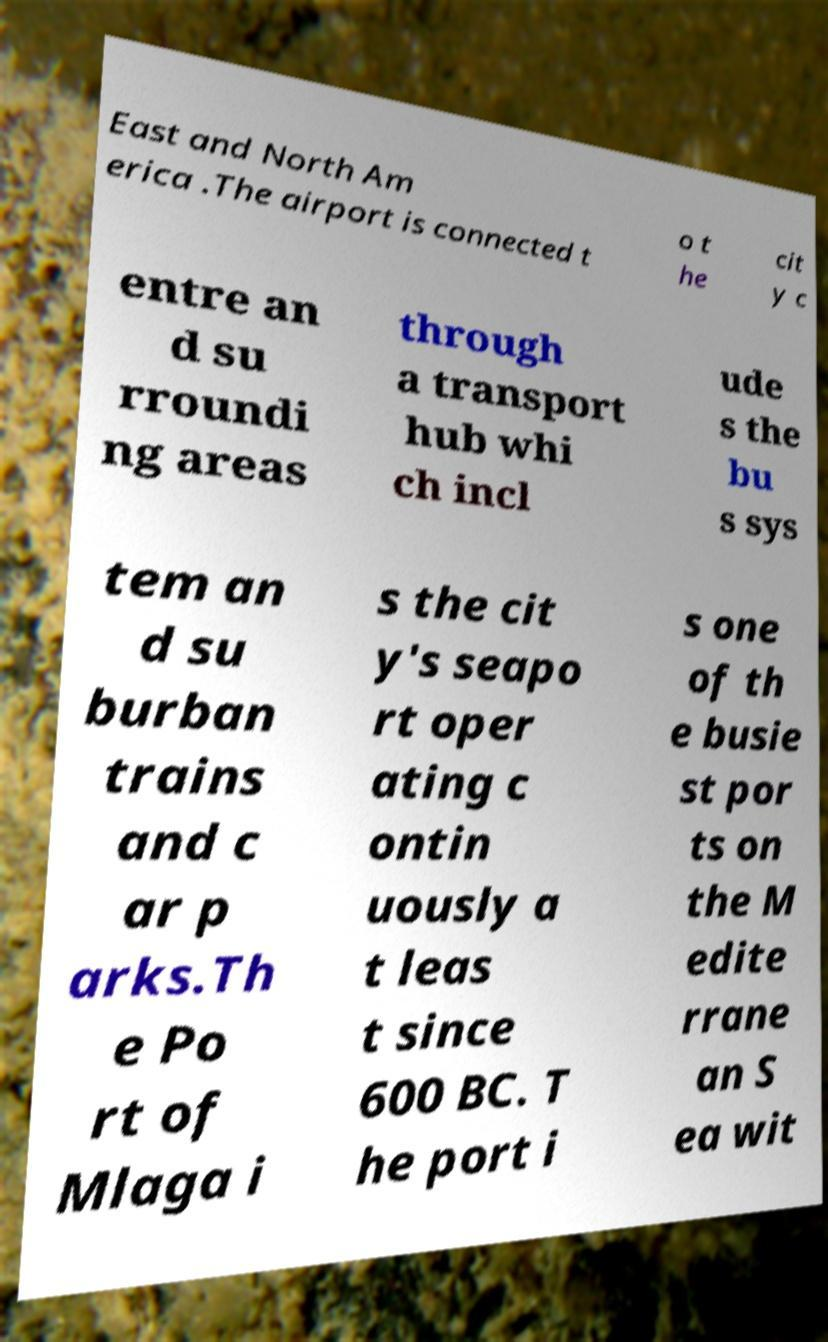Can you read and provide the text displayed in the image?This photo seems to have some interesting text. Can you extract and type it out for me? East and North Am erica .The airport is connected t o t he cit y c entre an d su rroundi ng areas through a transport hub whi ch incl ude s the bu s sys tem an d su burban trains and c ar p arks.Th e Po rt of Mlaga i s the cit y's seapo rt oper ating c ontin uously a t leas t since 600 BC. T he port i s one of th e busie st por ts on the M edite rrane an S ea wit 